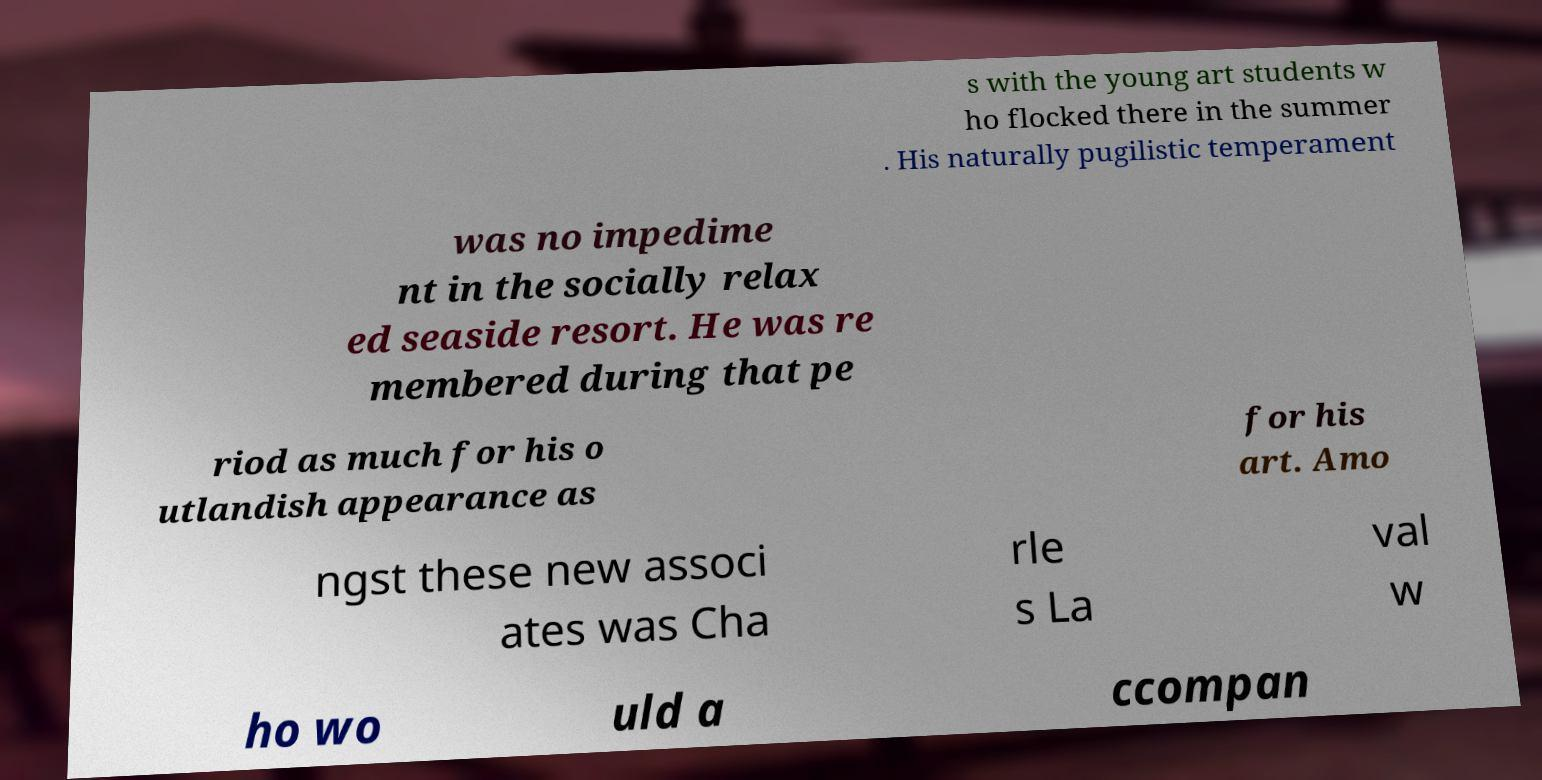I need the written content from this picture converted into text. Can you do that? s with the young art students w ho flocked there in the summer . His naturally pugilistic temperament was no impedime nt in the socially relax ed seaside resort. He was re membered during that pe riod as much for his o utlandish appearance as for his art. Amo ngst these new associ ates was Cha rle s La val w ho wo uld a ccompan 